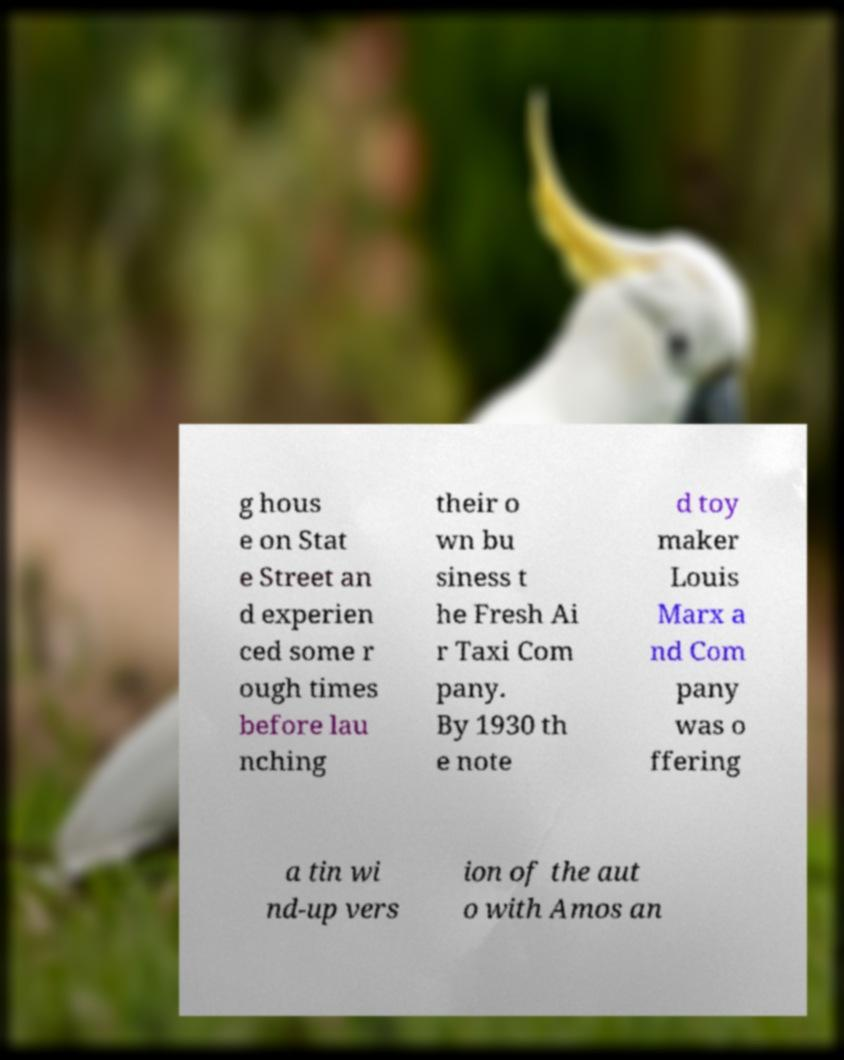What messages or text are displayed in this image? I need them in a readable, typed format. g hous e on Stat e Street an d experien ced some r ough times before lau nching their o wn bu siness t he Fresh Ai r Taxi Com pany. By 1930 th e note d toy maker Louis Marx a nd Com pany was o ffering a tin wi nd-up vers ion of the aut o with Amos an 